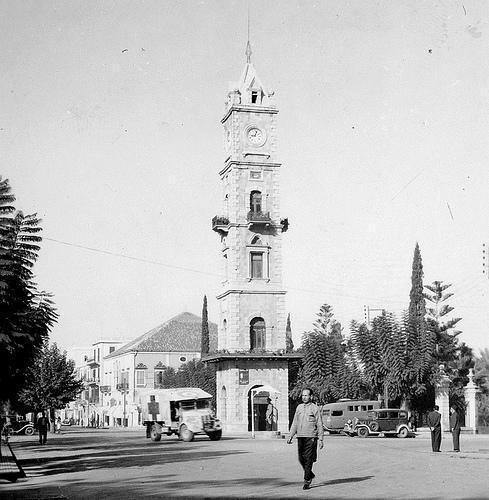How many ambulances are in the picture?
Give a very brief answer. 1. How many vehicles are parked by the clock tower?
Give a very brief answer. 2. 